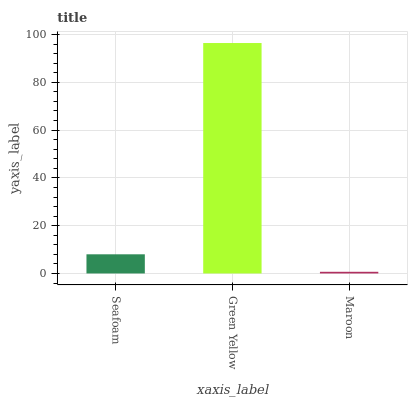Is Maroon the minimum?
Answer yes or no. Yes. Is Green Yellow the maximum?
Answer yes or no. Yes. Is Green Yellow the minimum?
Answer yes or no. No. Is Maroon the maximum?
Answer yes or no. No. Is Green Yellow greater than Maroon?
Answer yes or no. Yes. Is Maroon less than Green Yellow?
Answer yes or no. Yes. Is Maroon greater than Green Yellow?
Answer yes or no. No. Is Green Yellow less than Maroon?
Answer yes or no. No. Is Seafoam the high median?
Answer yes or no. Yes. Is Seafoam the low median?
Answer yes or no. Yes. Is Green Yellow the high median?
Answer yes or no. No. Is Green Yellow the low median?
Answer yes or no. No. 